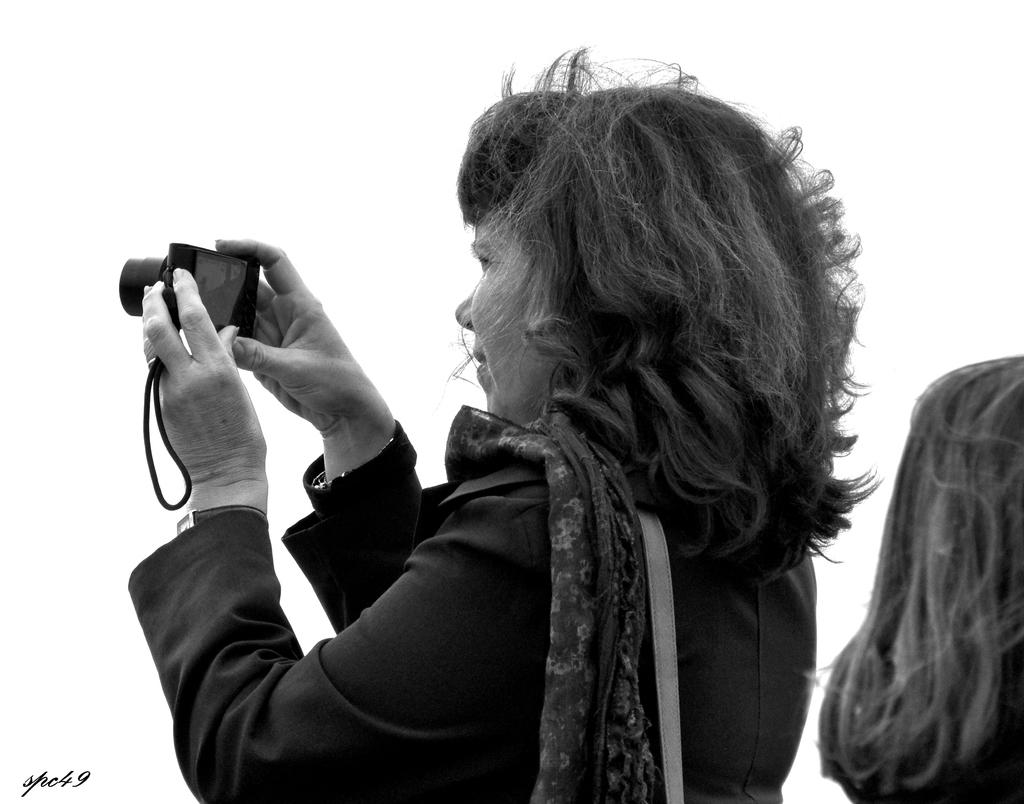How many people are in the image? There are two persons in the image. What are the positions of the persons in the image? Both persons are standing. What is one person holding in the image? One person is holding a camera. Can you see any boats in the image? There are no boats present in the image. Is there a pig visible in the image? There is no pig present in the image. 